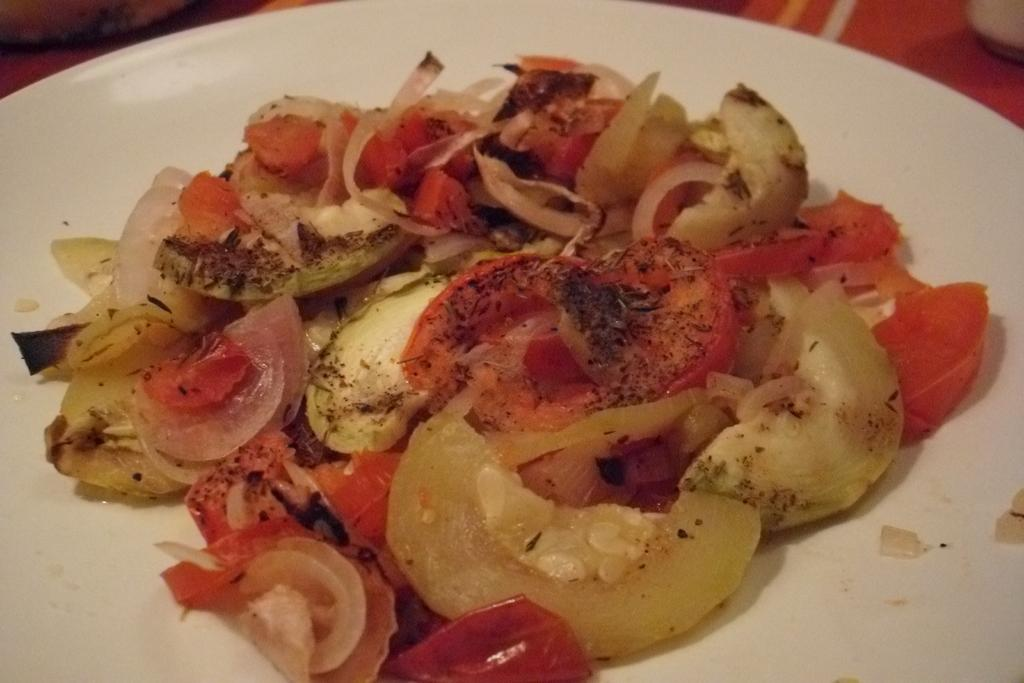What is present on the plate in the image? There are food items on a plate in the image. What type of throne is depicted in the image? There is no throne present in the image; it features a plate with food items. What type of crime is being committed in the image? There is no crime depicted in the image; it features a plate with food items. 